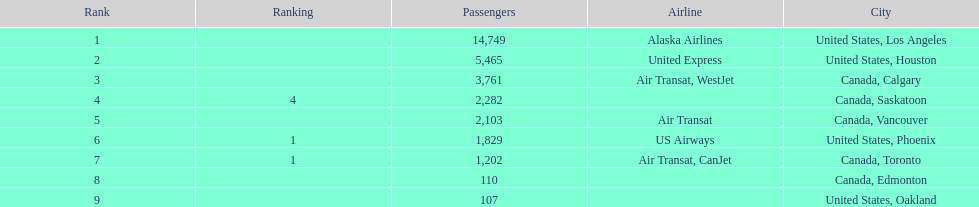The difference in passengers between los angeles and toronto 13,547. 